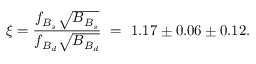<formula> <loc_0><loc_0><loc_500><loc_500>\xi = \frac { f _ { B _ { s } } \sqrt { B _ { B _ { s } } } } { f _ { B _ { d } } \sqrt { B _ { B _ { d } } } } = 1 . 1 7 \pm 0 . 0 6 \pm 0 . 1 2 .</formula> 